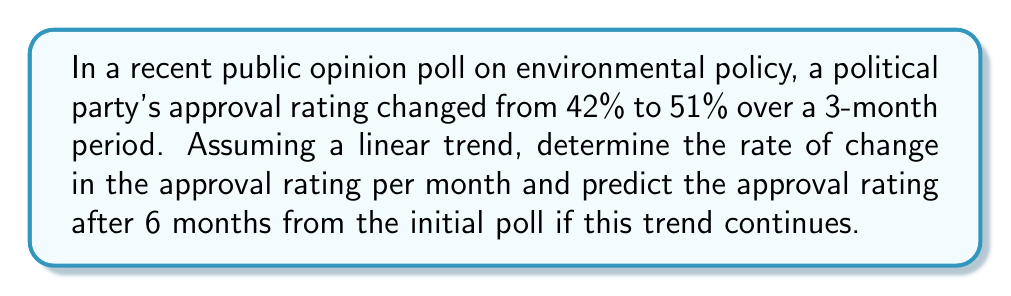Teach me how to tackle this problem. To solve this problem, we'll use a linear equation and follow these steps:

1. Calculate the rate of change:
   Let $y$ represent the approval rating and $x$ represent the time in months.
   
   Rate of change = $\frac{\text{Change in y}}{\text{Change in x}} = \frac{y_2 - y_1}{x_2 - x_1}$
   
   $$ \text{Rate of change} = \frac{51\% - 42\%}{3 - 0} = \frac{9\%}{3} = 3\% \text{ per month} $$

2. Form the linear equation:
   $y = mx + b$, where $m$ is the rate of change and $b$ is the initial approval rating.
   
   $y = 3x + 42$

3. Predict the approval rating after 6 months:
   Substitute $x = 6$ into the equation:
   
   $y = 3(6) + 42 = 18 + 42 = 60$

Therefore, the predicted approval rating after 6 months is 60%.
Answer: 3% per month; 60% after 6 months 